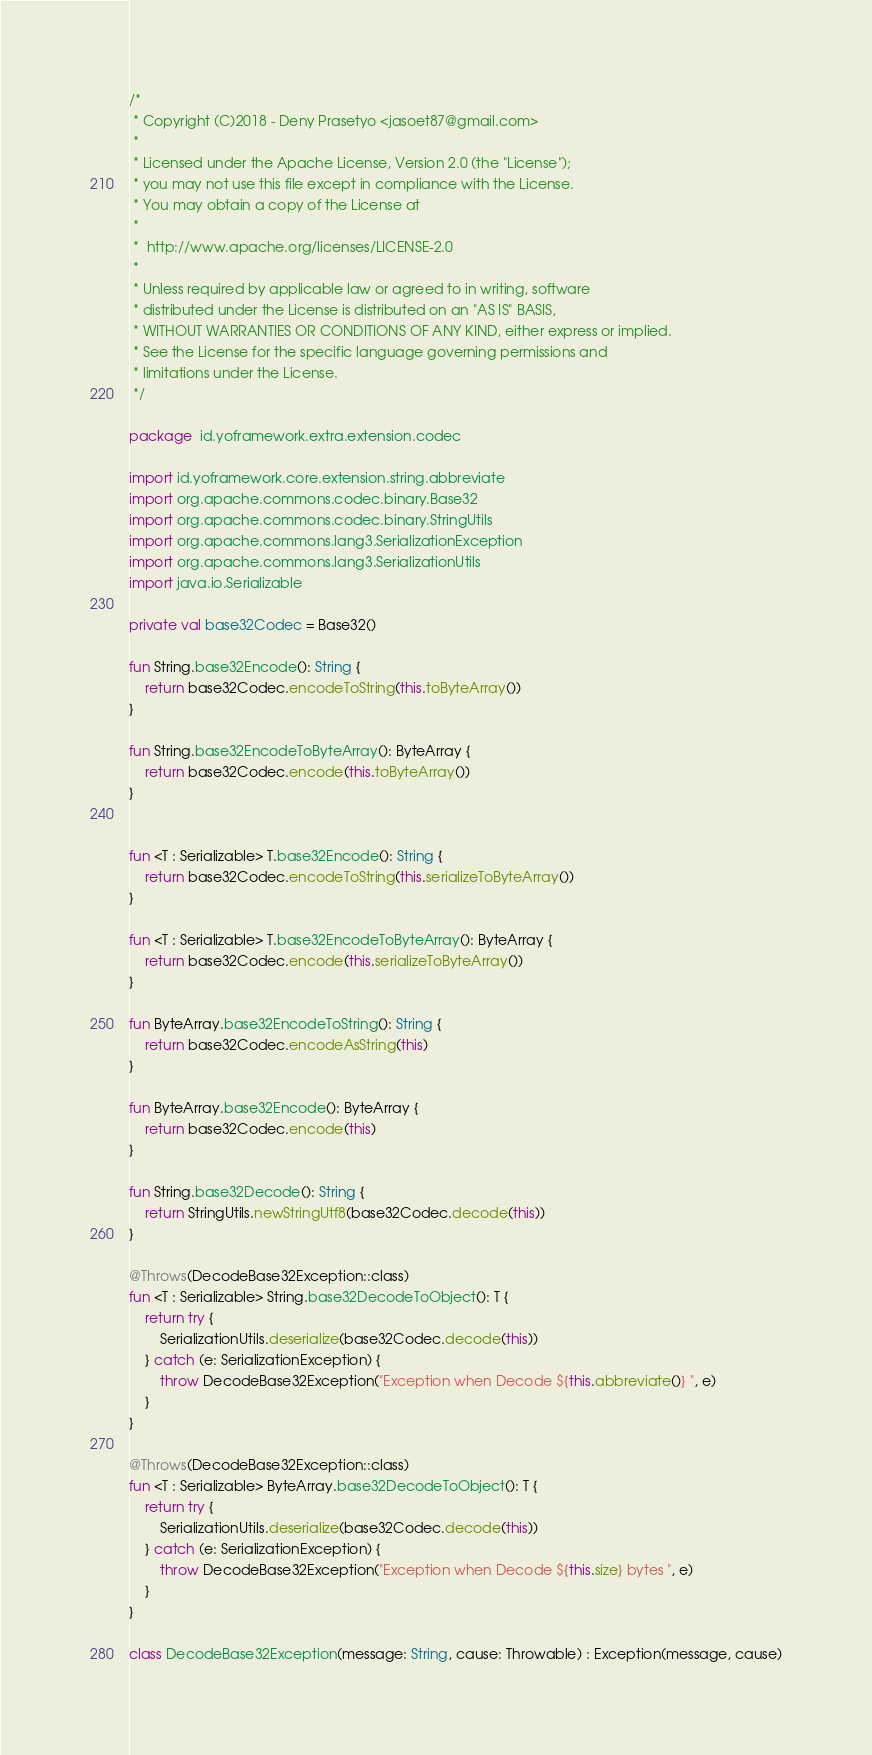Convert code to text. <code><loc_0><loc_0><loc_500><loc_500><_Kotlin_>/*
 * Copyright (C)2018 - Deny Prasetyo <jasoet87@gmail.com>
 *
 * Licensed under the Apache License, Version 2.0 (the "License");
 * you may not use this file except in compliance with the License.
 * You may obtain a copy of the License at
 *
 *  http://www.apache.org/licenses/LICENSE-2.0
 *
 * Unless required by applicable law or agreed to in writing, software
 * distributed under the License is distributed on an "AS IS" BASIS,
 * WITHOUT WARRANTIES OR CONDITIONS OF ANY KIND, either express or implied.
 * See the License for the specific language governing permissions and
 * limitations under the License.
 */

package  id.yoframework.extra.extension.codec

import id.yoframework.core.extension.string.abbreviate
import org.apache.commons.codec.binary.Base32
import org.apache.commons.codec.binary.StringUtils
import org.apache.commons.lang3.SerializationException
import org.apache.commons.lang3.SerializationUtils
import java.io.Serializable

private val base32Codec = Base32()

fun String.base32Encode(): String {
    return base32Codec.encodeToString(this.toByteArray())
}

fun String.base32EncodeToByteArray(): ByteArray {
    return base32Codec.encode(this.toByteArray())
}


fun <T : Serializable> T.base32Encode(): String {
    return base32Codec.encodeToString(this.serializeToByteArray())
}

fun <T : Serializable> T.base32EncodeToByteArray(): ByteArray {
    return base32Codec.encode(this.serializeToByteArray())
}

fun ByteArray.base32EncodeToString(): String {
    return base32Codec.encodeAsString(this)
}

fun ByteArray.base32Encode(): ByteArray {
    return base32Codec.encode(this)
}

fun String.base32Decode(): String {
    return StringUtils.newStringUtf8(base32Codec.decode(this))
}

@Throws(DecodeBase32Exception::class)
fun <T : Serializable> String.base32DecodeToObject(): T {
    return try {
        SerializationUtils.deserialize(base32Codec.decode(this))
    } catch (e: SerializationException) {
        throw DecodeBase32Exception("Exception when Decode ${this.abbreviate()} ", e)
    }
}

@Throws(DecodeBase32Exception::class)
fun <T : Serializable> ByteArray.base32DecodeToObject(): T {
    return try {
        SerializationUtils.deserialize(base32Codec.decode(this))
    } catch (e: SerializationException) {
        throw DecodeBase32Exception("Exception when Decode ${this.size} bytes ", e)
    }
}

class DecodeBase32Exception(message: String, cause: Throwable) : Exception(message, cause)
</code> 